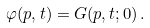Convert formula to latex. <formula><loc_0><loc_0><loc_500><loc_500>\varphi ( p , t ) = G ( p , t ; 0 ) \, .</formula> 